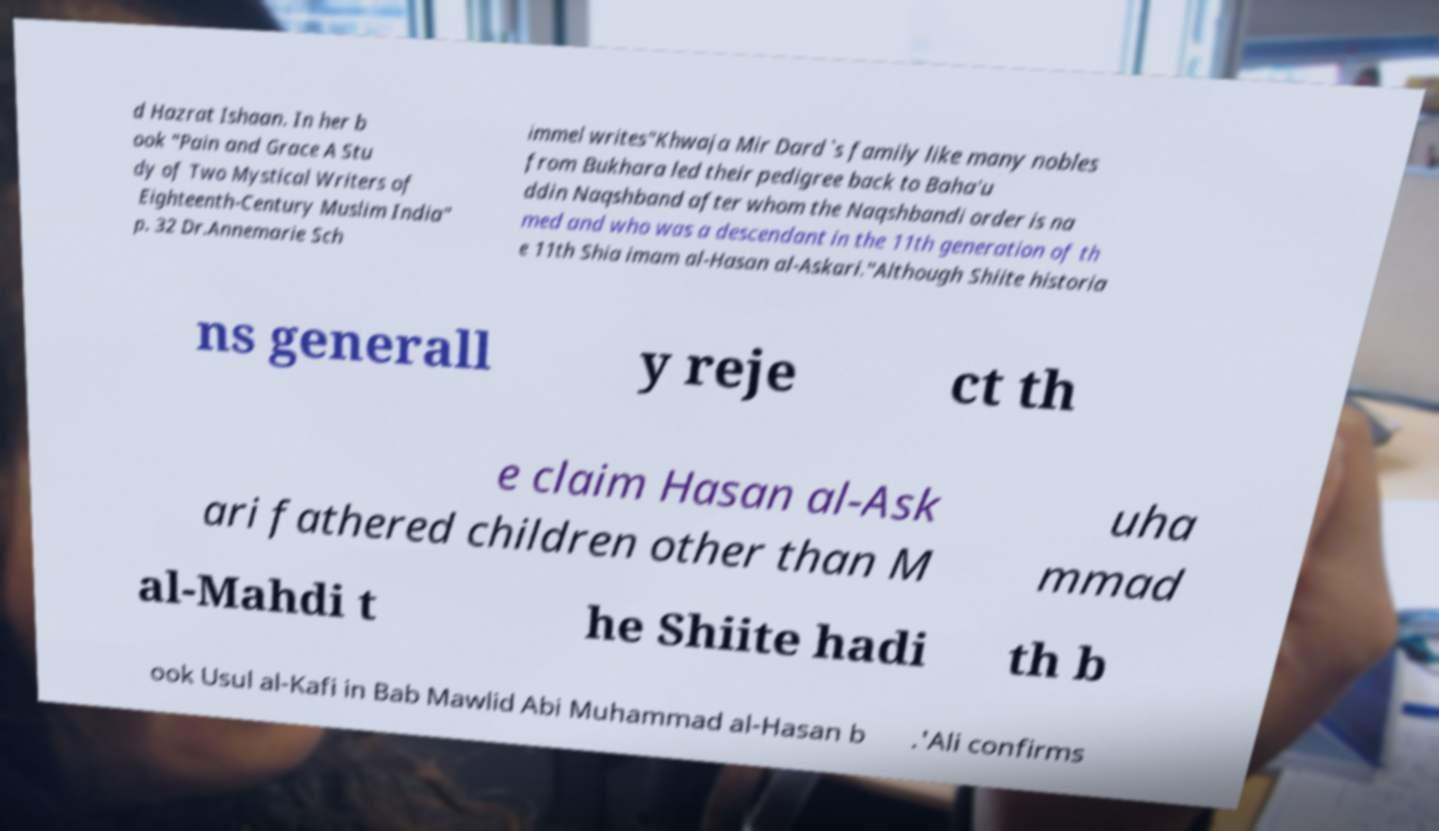Can you accurately transcribe the text from the provided image for me? d Hazrat Ishaan. In her b ook "Pain and Grace A Stu dy of Two Mystical Writers of Eighteenth-Century Muslim India" p. 32 Dr.Annemarie Sch immel writes"Khwaja Mir Dard`s family like many nobles from Bukhara led their pedigree back to Baha'u ddin Naqshband after whom the Naqshbandi order is na med and who was a descendant in the 11th generation of th e 11th Shia imam al-Hasan al-Askari."Although Shiite historia ns generall y reje ct th e claim Hasan al-Ask ari fathered children other than M uha mmad al-Mahdi t he Shiite hadi th b ook Usul al-Kafi in Bab Mawlid Abi Muhammad al-Hasan b .'Ali confirms 